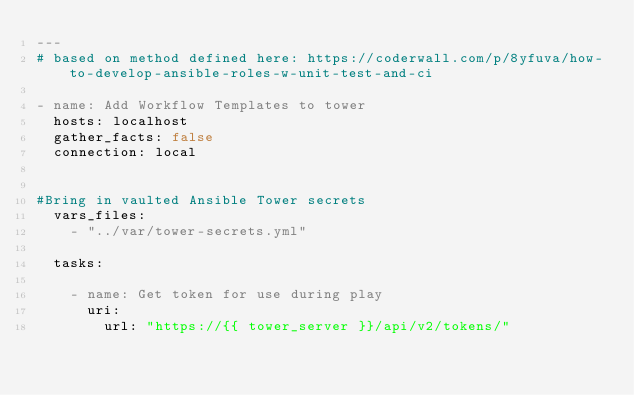<code> <loc_0><loc_0><loc_500><loc_500><_YAML_>---
# based on method defined here: https://coderwall.com/p/8yfuva/how-to-develop-ansible-roles-w-unit-test-and-ci

- name: Add Workflow Templates to tower
  hosts: localhost
  gather_facts: false
  connection: local


#Bring in vaulted Ansible Tower secrets
  vars_files:
    - "../var/tower-secrets.yml"

  tasks:

    - name: Get token for use during play
      uri:
        url: "https://{{ tower_server }}/api/v2/tokens/"</code> 